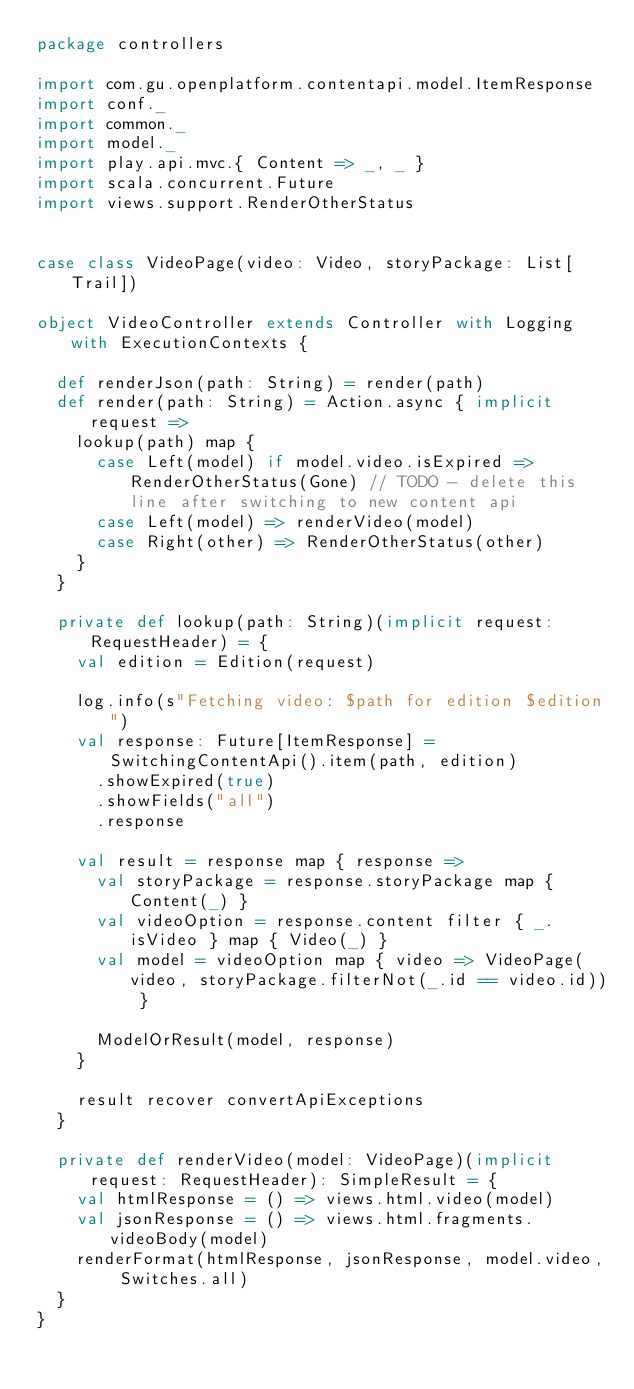<code> <loc_0><loc_0><loc_500><loc_500><_Scala_>package controllers

import com.gu.openplatform.contentapi.model.ItemResponse
import conf._
import common._
import model._
import play.api.mvc.{ Content => _, _ }
import scala.concurrent.Future
import views.support.RenderOtherStatus


case class VideoPage(video: Video, storyPackage: List[Trail])

object VideoController extends Controller with Logging with ExecutionContexts {

  def renderJson(path: String) = render(path)
  def render(path: String) = Action.async { implicit request =>
    lookup(path) map {
      case Left(model) if model.video.isExpired => RenderOtherStatus(Gone) // TODO - delete this line after switching to new content api
      case Left(model) => renderVideo(model)
      case Right(other) => RenderOtherStatus(other)
    }
  }

  private def lookup(path: String)(implicit request: RequestHeader) = {
    val edition = Edition(request)

    log.info(s"Fetching video: $path for edition $edition")
    val response: Future[ItemResponse] = SwitchingContentApi().item(path, edition)
      .showExpired(true)
      .showFields("all")
      .response

    val result = response map { response =>
      val storyPackage = response.storyPackage map { Content(_) }
      val videoOption = response.content filter { _.isVideo } map { Video(_) }
      val model = videoOption map { video => VideoPage(video, storyPackage.filterNot(_.id == video.id)) }

      ModelOrResult(model, response)
    }

    result recover convertApiExceptions
  }

  private def renderVideo(model: VideoPage)(implicit request: RequestHeader): SimpleResult = {
    val htmlResponse = () => views.html.video(model)
    val jsonResponse = () => views.html.fragments.videoBody(model)
    renderFormat(htmlResponse, jsonResponse, model.video, Switches.all)
  }
}
</code> 